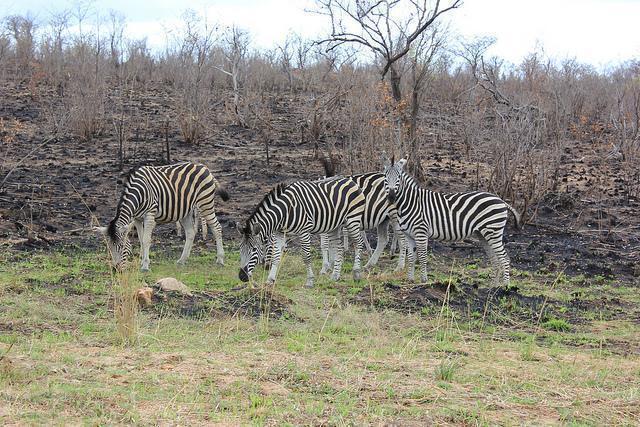What are these animals known for?
From the following set of four choices, select the accurate answer to respond to the question.
Options: Stripes, tusks, horns, antlers. Stripes. 